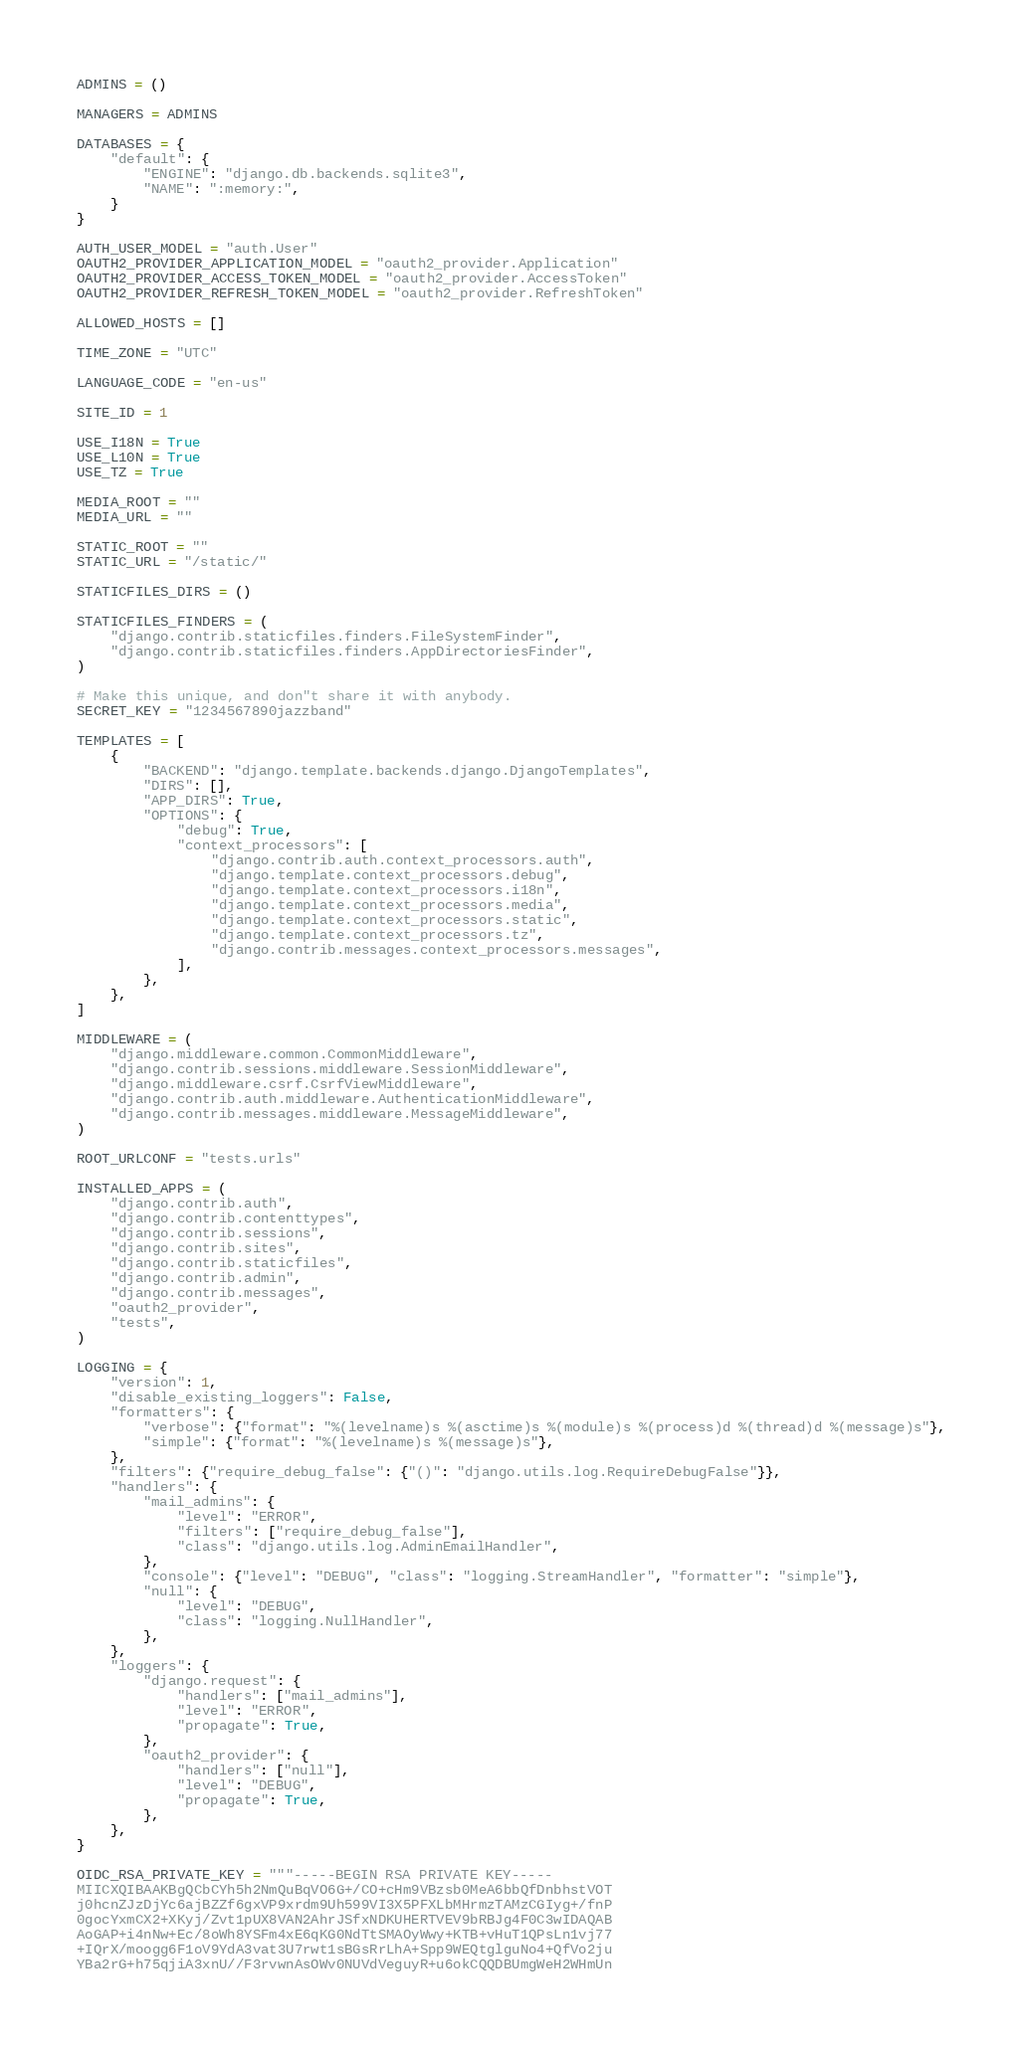Convert code to text. <code><loc_0><loc_0><loc_500><loc_500><_Python_>ADMINS = ()

MANAGERS = ADMINS

DATABASES = {
    "default": {
        "ENGINE": "django.db.backends.sqlite3",
        "NAME": ":memory:",
    }
}

AUTH_USER_MODEL = "auth.User"
OAUTH2_PROVIDER_APPLICATION_MODEL = "oauth2_provider.Application"
OAUTH2_PROVIDER_ACCESS_TOKEN_MODEL = "oauth2_provider.AccessToken"
OAUTH2_PROVIDER_REFRESH_TOKEN_MODEL = "oauth2_provider.RefreshToken"

ALLOWED_HOSTS = []

TIME_ZONE = "UTC"

LANGUAGE_CODE = "en-us"

SITE_ID = 1

USE_I18N = True
USE_L10N = True
USE_TZ = True

MEDIA_ROOT = ""
MEDIA_URL = ""

STATIC_ROOT = ""
STATIC_URL = "/static/"

STATICFILES_DIRS = ()

STATICFILES_FINDERS = (
    "django.contrib.staticfiles.finders.FileSystemFinder",
    "django.contrib.staticfiles.finders.AppDirectoriesFinder",
)

# Make this unique, and don"t share it with anybody.
SECRET_KEY = "1234567890jazzband"

TEMPLATES = [
    {
        "BACKEND": "django.template.backends.django.DjangoTemplates",
        "DIRS": [],
        "APP_DIRS": True,
        "OPTIONS": {
            "debug": True,
            "context_processors": [
                "django.contrib.auth.context_processors.auth",
                "django.template.context_processors.debug",
                "django.template.context_processors.i18n",
                "django.template.context_processors.media",
                "django.template.context_processors.static",
                "django.template.context_processors.tz",
                "django.contrib.messages.context_processors.messages",
            ],
        },
    },
]

MIDDLEWARE = (
    "django.middleware.common.CommonMiddleware",
    "django.contrib.sessions.middleware.SessionMiddleware",
    "django.middleware.csrf.CsrfViewMiddleware",
    "django.contrib.auth.middleware.AuthenticationMiddleware",
    "django.contrib.messages.middleware.MessageMiddleware",
)

ROOT_URLCONF = "tests.urls"

INSTALLED_APPS = (
    "django.contrib.auth",
    "django.contrib.contenttypes",
    "django.contrib.sessions",
    "django.contrib.sites",
    "django.contrib.staticfiles",
    "django.contrib.admin",
    "django.contrib.messages",
    "oauth2_provider",
    "tests",
)

LOGGING = {
    "version": 1,
    "disable_existing_loggers": False,
    "formatters": {
        "verbose": {"format": "%(levelname)s %(asctime)s %(module)s %(process)d %(thread)d %(message)s"},
        "simple": {"format": "%(levelname)s %(message)s"},
    },
    "filters": {"require_debug_false": {"()": "django.utils.log.RequireDebugFalse"}},
    "handlers": {
        "mail_admins": {
            "level": "ERROR",
            "filters": ["require_debug_false"],
            "class": "django.utils.log.AdminEmailHandler",
        },
        "console": {"level": "DEBUG", "class": "logging.StreamHandler", "formatter": "simple"},
        "null": {
            "level": "DEBUG",
            "class": "logging.NullHandler",
        },
    },
    "loggers": {
        "django.request": {
            "handlers": ["mail_admins"],
            "level": "ERROR",
            "propagate": True,
        },
        "oauth2_provider": {
            "handlers": ["null"],
            "level": "DEBUG",
            "propagate": True,
        },
    },
}

OIDC_RSA_PRIVATE_KEY = """-----BEGIN RSA PRIVATE KEY-----
MIICXQIBAAKBgQCbCYh5h2NmQuBqVO6G+/CO+cHm9VBzsb0MeA6bbQfDnbhstVOT
j0hcnZJzDjYc6ajBZZf6gxVP9xrdm9Uh599VI3X5PFXLbMHrmzTAMzCGIyg+/fnP
0gocYxmCX2+XKyj/Zvt1pUX8VAN2AhrJSfxNDKUHERTVEV9bRBJg4F0C3wIDAQAB
AoGAP+i4nNw+Ec/8oWh8YSFm4xE6qKG0NdTtSMAOyWwy+KTB+vHuT1QPsLn1vj77
+IQrX/moogg6F1oV9YdA3vat3U7rwt1sBGsRrLhA+Spp9WEQtglguNo4+QfVo2ju
YBa2rG+h75qjiA3xnU//F3rvwnAsOWv0NUVdVeguyR+u6okCQQDBUmgWeH2WHmUn</code> 